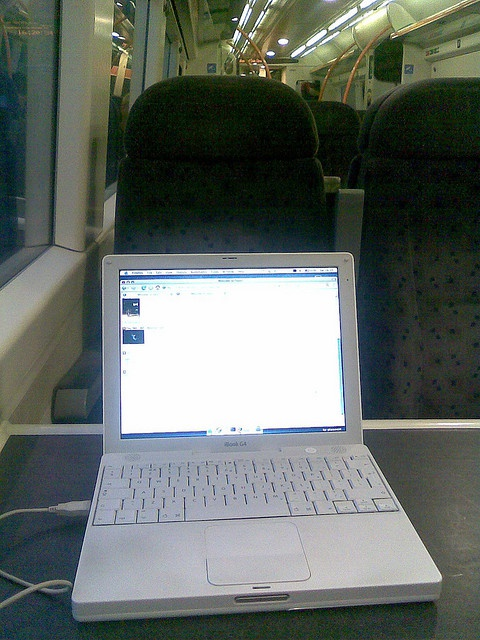Describe the objects in this image and their specific colors. I can see laptop in teal, darkgray, white, and gray tones, chair in teal, black, navy, darkblue, and gray tones, and chair in teal, black, darkgreen, and gray tones in this image. 